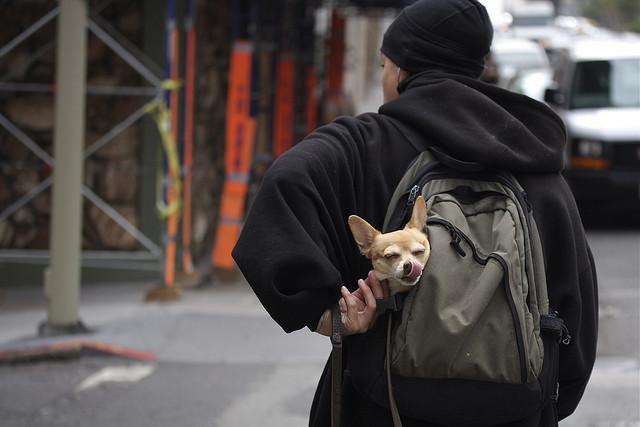Is the dog licking it's nose?
Quick response, please. Yes. What breed of dog is this?
Answer briefly. Chihuahua. What is in the bag?
Give a very brief answer. Dog. 